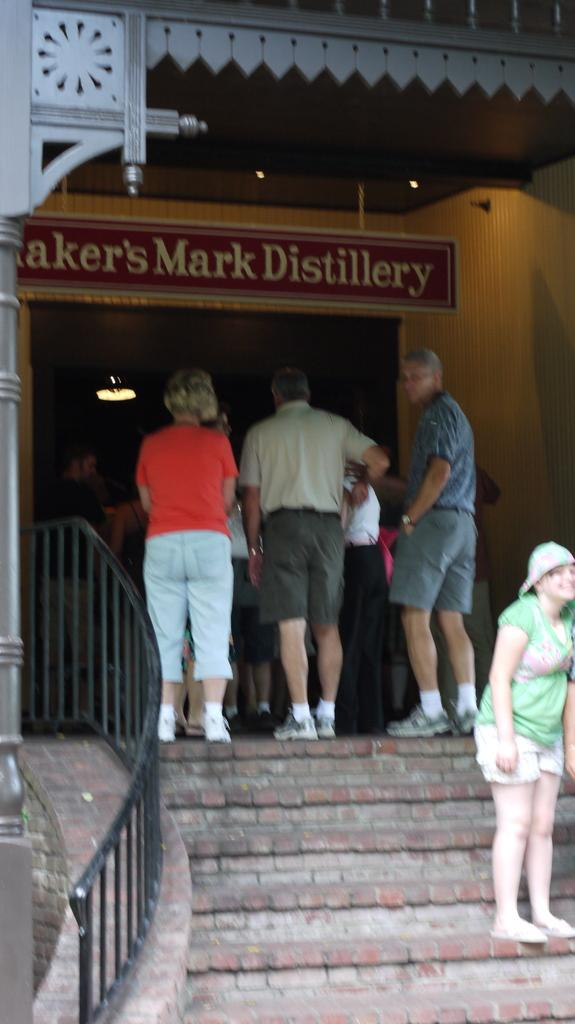What can be seen in the background of the image? There is a board in the background of the image. Who or what is present in the image? There are people in the image. What architectural feature is visible in the image? There are stairs in the image. What safety feature is present in the image? There is a railing in the image. What structural element can be seen in the image? There is a pillar in the image. What source of illumination is visible in the image? There are lights in the image. What type of father is depicted in the image? There is no father present in the image. What emotion can be seen on the faces of the people in the image? The provided facts do not mention any emotions or expressions of the people in the image. How many bikes are parked in the image? There are no bikes present in the image. 